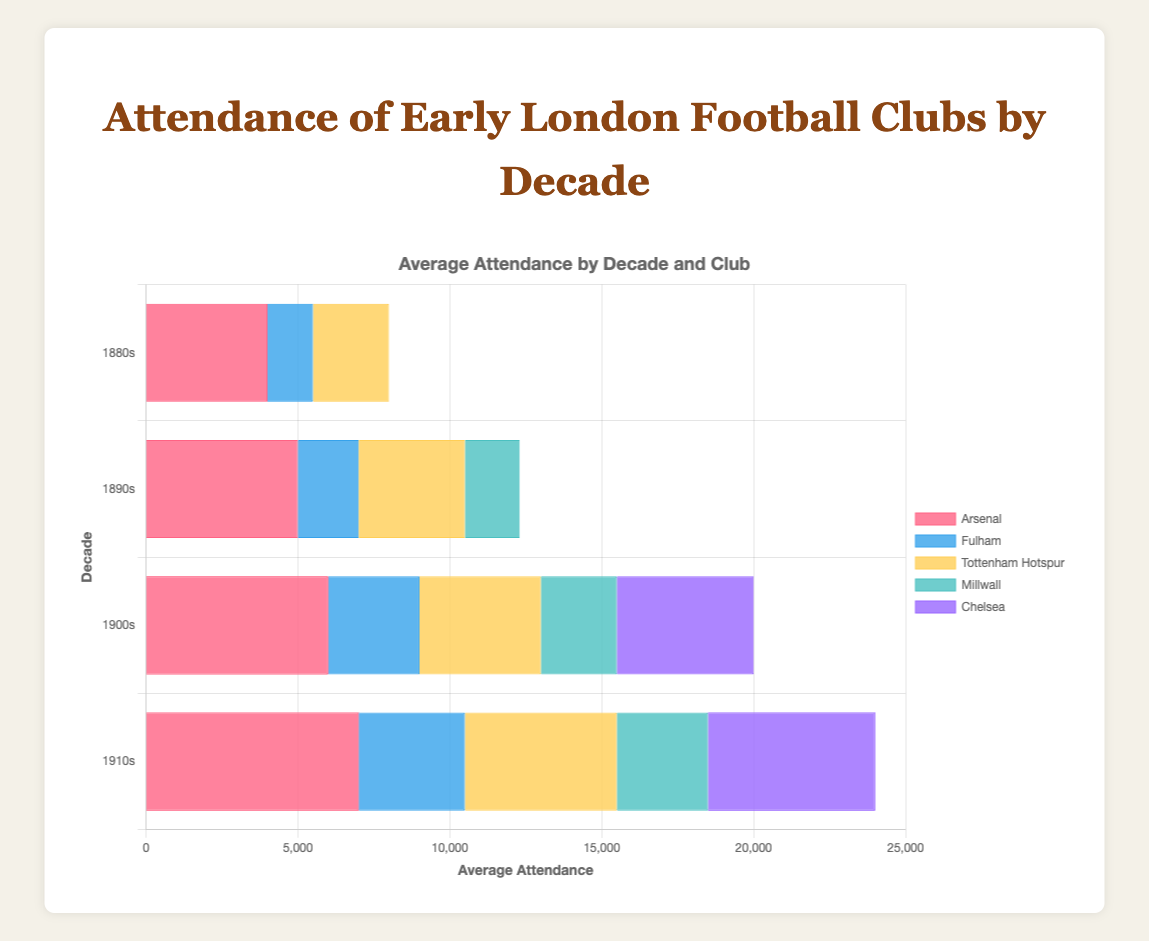1. Which decade had the highest average attendance for Arsenal? The highest average attendance for Arsenal can be found by looking for the tallest bar associated with Arsenal in each decade. The tallest bar corresponds to the 1910s with 7000.
Answer: 1910s 2. What was the average age of attendees for Fulham in the 1910s? Locate the bar for Fulham in the 1910s. Then check the label or value provided to find the average age. The figure states 34.
Answer: 34 3. How did the average attendance for Chelsea change from the 1900s to the 1910s? Compare the bars representing Chelsea in the 1900s and 1910s. In the 1900s, Chelsea had 4500, and in the 1910s, Chelsea had 5500, thus the difference is 5500 - 4500 = 1000.
Answer: Increased by 1000 4. Which club had the lowest average attendance in the 1880s? For the 1880s, compare the lengths of the bars for Arsenal, Fulham, and Tottenham Hotspur. Fulham has the shortest bar with 1500 average attendance.
Answer: Fulham 5. How many clubs are represented in the 1890s? Count the unique bars in the 1890s section of the chart. There are bars for Arsenal, Fulham, Tottenham Hotspur, and Millwall, so there are 4 clubs.
Answer: 4 6. What's the average attendance across all clubs in the 1900s? Sum the average attendances for all clubs in the 1900s: 6000 (Arsenal) + 3000 (Fulham) + 4000 (Tottenham Hotspur) + 2500 (Millwall) + 4500 (Chelsea) = 20000. There are 5 clubs, so the average is 20000/5 = 4000.
Answer: 4000 7. Which decade had the lowest overall attendance out of all the decades shown? Compare the total lengths of the bars for each decade. The 1880s have the lowest total with 4000 (Arsenal) + 1500 (Fulham) + 2500 (Tottenham Hotspur) = 8000.
Answer: 1880s 8. In which decade did Millwall have the highest average attendance? Look at the bars for Millwall across all decades. The highest bar corresponds to the 1910s with 3000.
Answer: 1910s 9. What is the difference in the average age of attendees between Arsenal and Millwall in the 1890s? Locate the average ages for both clubs in the 1890s. Arsenal’s average age is 30 and Millwall’s is 28, so the difference is 30 - 28 = 2.
Answer: 2 10. Which club had a consistent average attendance of 30 in the 1880s and 1890s? Look for the club with bars both in the 1880s and 1890s marked with an average age of 30. Arsenal had 4000 and 5000 attendance in the respective decades with an average age of 30 in both.
Answer: Arsenal 